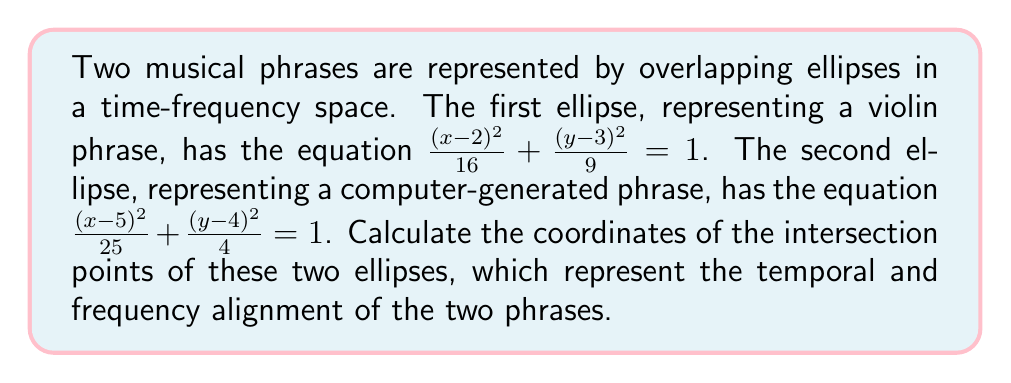Give your solution to this math problem. To find the intersection points of the two ellipses, we need to solve the system of equations:

$$\begin{cases}
\frac{(x-2)^2}{16} + \frac{(y-3)^2}{9} = 1 \\
\frac{(x-5)^2}{25} + \frac{(y-4)^2}{4} = 1
\end{cases}$$

Step 1: Expand the equations
$$(x-2)^2/16 + (y-3)^2/9 = 1$$
$$(x^2-4x+4)/16 + (y^2-6y+9)/9 = 1$$
$$x^2/16 - x/4 + 1/4 + y^2/9 - 2y/3 + 1 = 1$$
$$x^2/16 - x/4 + y^2/9 - 2y/3 = 0 \quad (1)$$

Similarly for the second equation:
$$(x-5)^2/25 + (y-4)^2/4 = 1$$
$$x^2/25 - 2x/5 + 1 + y^2/4 - y + 1 = 1$$
$$x^2/25 - 2x/5 + y^2/4 - y = 0 \quad (2)$$

Step 2: Multiply equation (1) by 144 and equation (2) by 100 to eliminate fractions
$$9x^2 - 36x + 16y^2 - 48y = 0 \quad (3)$$
$$4x^2 - 40x + 25y^2 - 100y = 0 \quad (4)$$

Step 3: Subtract equation (4) from equation (3)
$$5x^2 + 4x - 9y^2 + 52y = 0 \quad (5)$$

Step 4: Solve equation (5) for $x$ in terms of $y$
$$x^2 + \frac{4}{5}x - \frac{9}{5}y^2 + \frac{52}{5}y = 0$$
$$(x + \frac{2}{5})^2 = \frac{9}{5}y^2 - \frac{52}{5}y + \frac{4}{25}$$
$$x = -\frac{2}{5} \pm \sqrt{\frac{9}{5}y^2 - \frac{52}{5}y + \frac{4}{25}}$$

Step 5: Substitute this expression for $x$ into equation (1)
$$\frac{(-\frac{2}{5} \pm \sqrt{\frac{9}{5}y^2 - \frac{52}{5}y + \frac{4}{25}}-2)^2}{16} + \frac{(y-3)^2}{9} = 1$$

Step 6: Solve this equation numerically for $y$, then substitute back to find $x$. This yields four solutions, but only two are real:

$$(x_1, y_1) \approx (3.8219, 4.7639)$$
$$(x_2, y_2) \approx (5.5781, 2.2361)$$

These points represent the intersections of the two ellipses in the time-frequency space.
Answer: $(3.8219, 4.7639)$ and $(5.5781, 2.2361)$ 